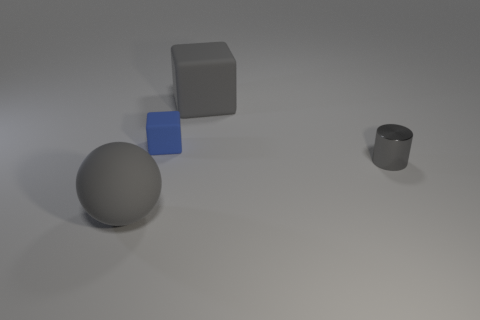Is the number of small gray shiny objects that are left of the large ball less than the number of tiny gray cylinders?
Provide a short and direct response. Yes. Does the thing behind the tiny blue rubber thing have the same material as the gray cylinder?
Provide a succinct answer. No. There is a small block that is made of the same material as the big gray ball; what color is it?
Ensure brevity in your answer.  Blue. Are there fewer shiny cylinders that are in front of the tiny cylinder than big gray objects that are on the right side of the tiny blue rubber cube?
Your answer should be compact. Yes. There is a thing in front of the tiny gray metal cylinder; does it have the same color as the big thing that is behind the small rubber object?
Ensure brevity in your answer.  Yes. Is there a big gray object made of the same material as the blue cube?
Keep it short and to the point. Yes. There is a gray object that is to the right of the gray rubber thing that is on the right side of the gray ball; how big is it?
Your response must be concise. Small. Are there more large gray rubber things than blue spheres?
Make the answer very short. Yes. Is the size of the rubber thing in front of the gray shiny cylinder the same as the small cylinder?
Your answer should be very brief. No. How many tiny metal cylinders have the same color as the large ball?
Provide a short and direct response. 1. 